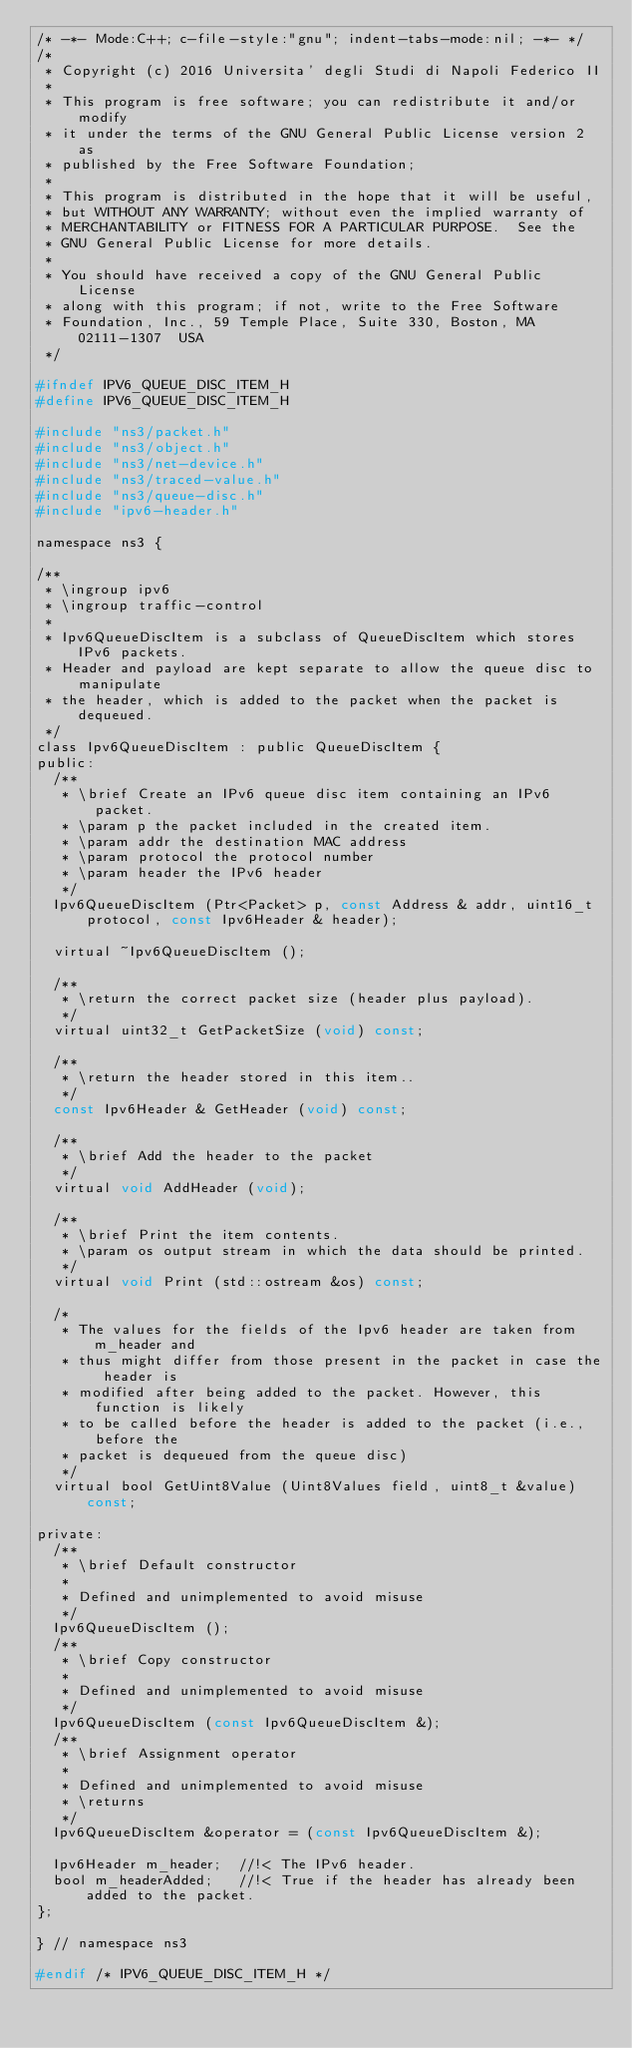<code> <loc_0><loc_0><loc_500><loc_500><_C_>/* -*- Mode:C++; c-file-style:"gnu"; indent-tabs-mode:nil; -*- */
/*
 * Copyright (c) 2016 Universita' degli Studi di Napoli Federico II
 *
 * This program is free software; you can redistribute it and/or modify
 * it under the terms of the GNU General Public License version 2 as
 * published by the Free Software Foundation;
 *
 * This program is distributed in the hope that it will be useful,
 * but WITHOUT ANY WARRANTY; without even the implied warranty of
 * MERCHANTABILITY or FITNESS FOR A PARTICULAR PURPOSE.  See the
 * GNU General Public License for more details.
 *
 * You should have received a copy of the GNU General Public License
 * along with this program; if not, write to the Free Software
 * Foundation, Inc., 59 Temple Place, Suite 330, Boston, MA  02111-1307  USA
 */

#ifndef IPV6_QUEUE_DISC_ITEM_H
#define IPV6_QUEUE_DISC_ITEM_H

#include "ns3/packet.h"
#include "ns3/object.h"
#include "ns3/net-device.h"
#include "ns3/traced-value.h"
#include "ns3/queue-disc.h"
#include "ipv6-header.h"

namespace ns3 {

/**
 * \ingroup ipv6
 * \ingroup traffic-control
 *
 * Ipv6QueueDiscItem is a subclass of QueueDiscItem which stores IPv6 packets.
 * Header and payload are kept separate to allow the queue disc to manipulate
 * the header, which is added to the packet when the packet is dequeued.
 */
class Ipv6QueueDiscItem : public QueueDiscItem {
public:
  /**
   * \brief Create an IPv6 queue disc item containing an IPv6 packet.
   * \param p the packet included in the created item.
   * \param addr the destination MAC address
   * \param protocol the protocol number
   * \param header the IPv6 header
   */
  Ipv6QueueDiscItem (Ptr<Packet> p, const Address & addr, uint16_t protocol, const Ipv6Header & header);

  virtual ~Ipv6QueueDiscItem ();

  /**
   * \return the correct packet size (header plus payload).
   */
  virtual uint32_t GetPacketSize (void) const;

  /**
   * \return the header stored in this item..
   */
  const Ipv6Header & GetHeader (void) const;

  /**
   * \brief Add the header to the packet
   */
  virtual void AddHeader (void);

  /**
   * \brief Print the item contents.
   * \param os output stream in which the data should be printed.
   */
  virtual void Print (std::ostream &os) const;

  /*
   * The values for the fields of the Ipv6 header are taken from m_header and
   * thus might differ from those present in the packet in case the header is
   * modified after being added to the packet. However, this function is likely
   * to be called before the header is added to the packet (i.e., before the
   * packet is dequeued from the queue disc)
   */
  virtual bool GetUint8Value (Uint8Values field, uint8_t &value) const;

private:
  /**
   * \brief Default constructor
   *
   * Defined and unimplemented to avoid misuse
   */
  Ipv6QueueDiscItem ();
  /**
   * \brief Copy constructor
   *
   * Defined and unimplemented to avoid misuse
   */
  Ipv6QueueDiscItem (const Ipv6QueueDiscItem &);
  /**
   * \brief Assignment operator
   *
   * Defined and unimplemented to avoid misuse
   * \returns
   */
  Ipv6QueueDiscItem &operator = (const Ipv6QueueDiscItem &);

  Ipv6Header m_header;  //!< The IPv6 header.
  bool m_headerAdded;   //!< True if the header has already been added to the packet.
};

} // namespace ns3

#endif /* IPV6_QUEUE_DISC_ITEM_H */
</code> 